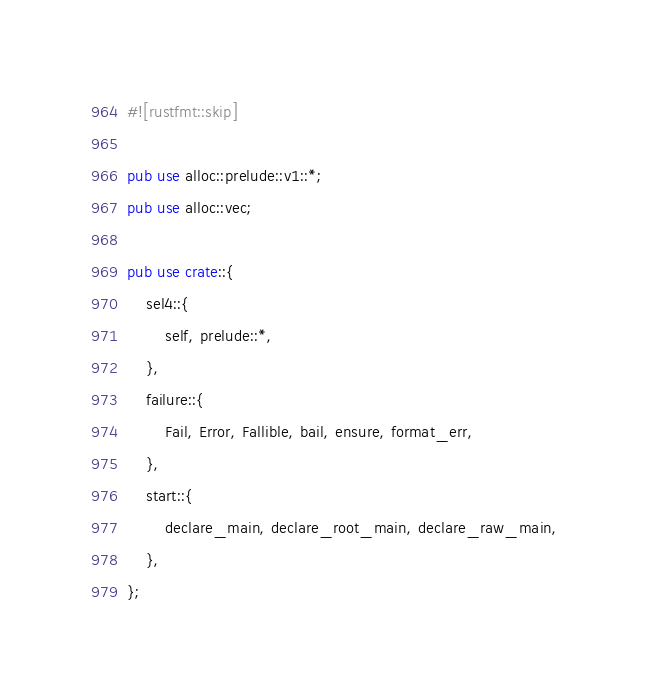Convert code to text. <code><loc_0><loc_0><loc_500><loc_500><_Rust_>#![rustfmt::skip]

pub use alloc::prelude::v1::*;
pub use alloc::vec;

pub use crate::{
    sel4::{
        self, prelude::*,
    },
    failure::{
        Fail, Error, Fallible, bail, ensure, format_err,
    },
    start::{
        declare_main, declare_root_main, declare_raw_main,
    },
};
</code> 